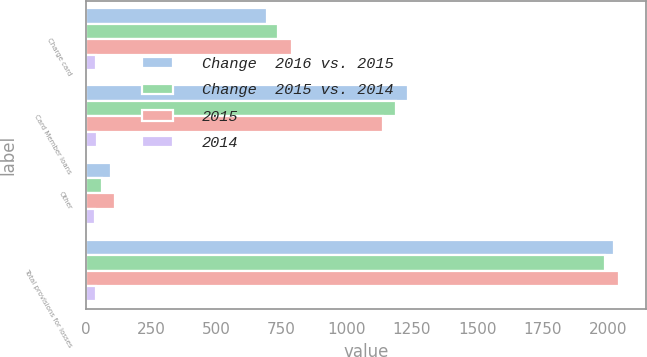<chart> <loc_0><loc_0><loc_500><loc_500><stacked_bar_chart><ecel><fcel>Charge card<fcel>Card Member loans<fcel>Other<fcel>Total provisions for losses<nl><fcel>Change  2016 vs. 2015<fcel>696<fcel>1235<fcel>95<fcel>2026<nl><fcel>Change  2015 vs. 2014<fcel>737<fcel>1190<fcel>61<fcel>1988<nl><fcel>2015<fcel>792<fcel>1138<fcel>114<fcel>2044<nl><fcel>2014<fcel>41<fcel>45<fcel>34<fcel>38<nl></chart> 